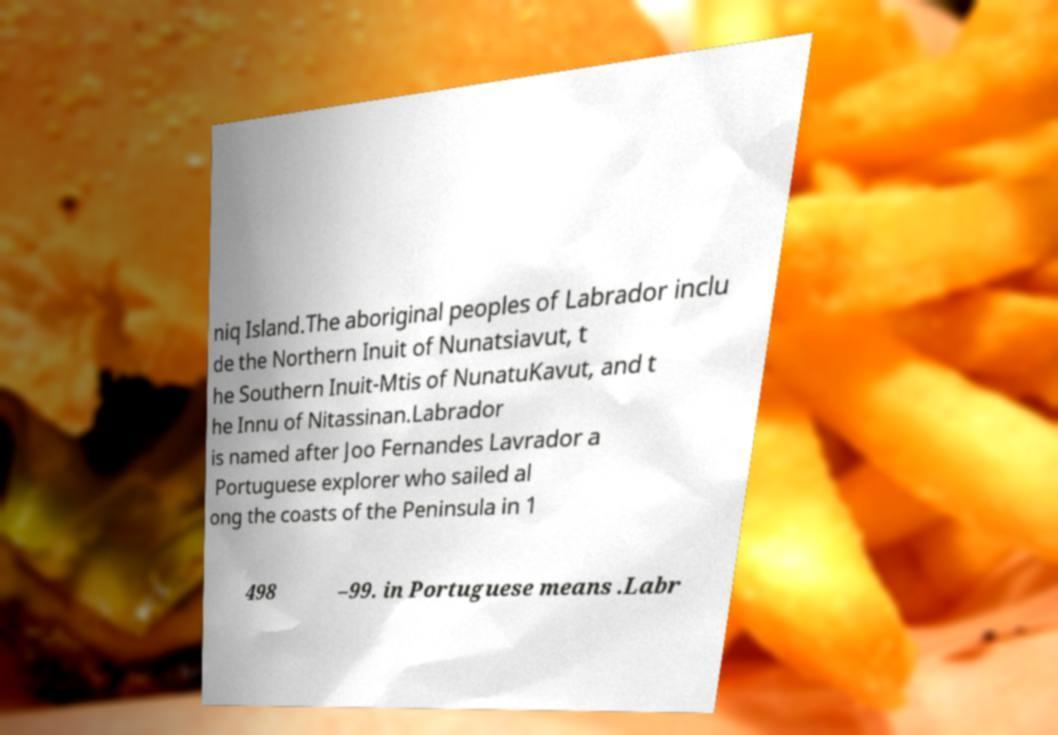Can you accurately transcribe the text from the provided image for me? niq Island.The aboriginal peoples of Labrador inclu de the Northern Inuit of Nunatsiavut, t he Southern Inuit-Mtis of NunatuKavut, and t he Innu of Nitassinan.Labrador is named after Joo Fernandes Lavrador a Portuguese explorer who sailed al ong the coasts of the Peninsula in 1 498 –99. in Portuguese means .Labr 